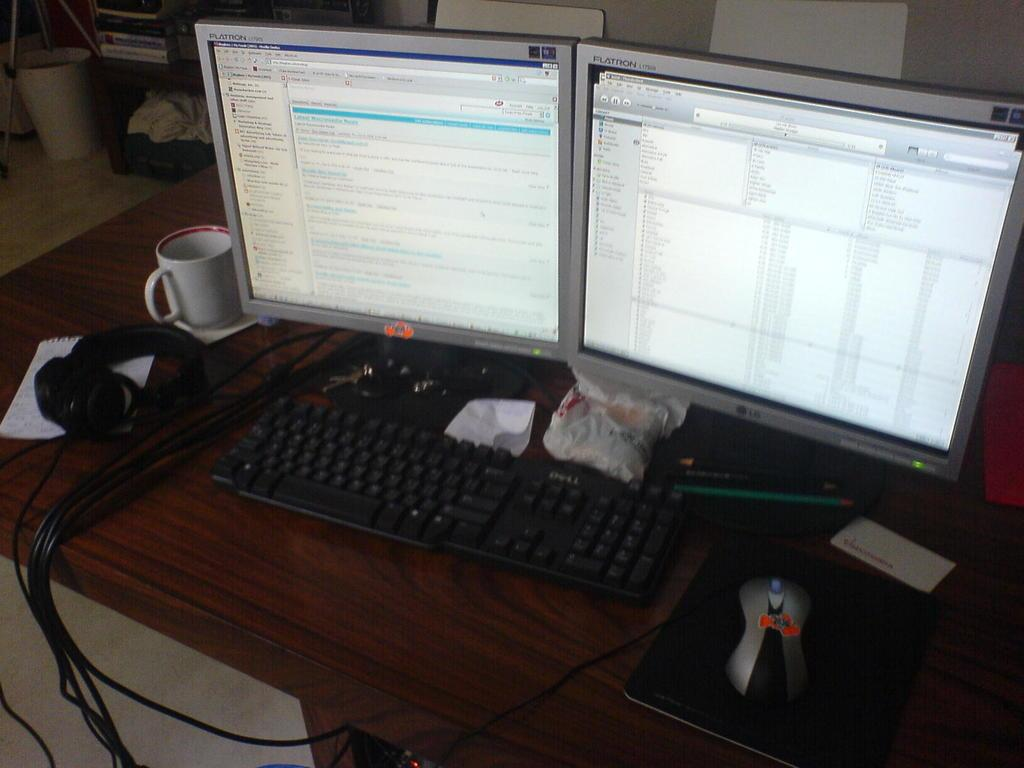Provide a one-sentence caption for the provided image. A keyboard with two monitors in front next to a mouse with a 2036 sticker. 